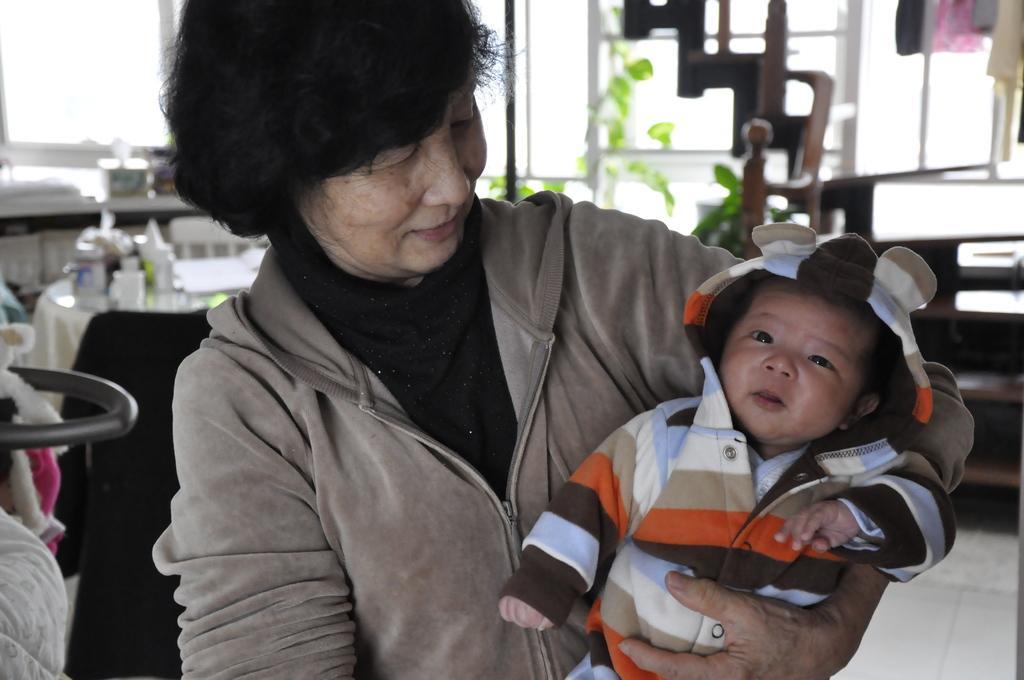In one or two sentences, can you explain what this image depicts? In this picture there is a lady in the center of the image, by holding a baby in her hands and there is a table and windows in the background area of the image. 